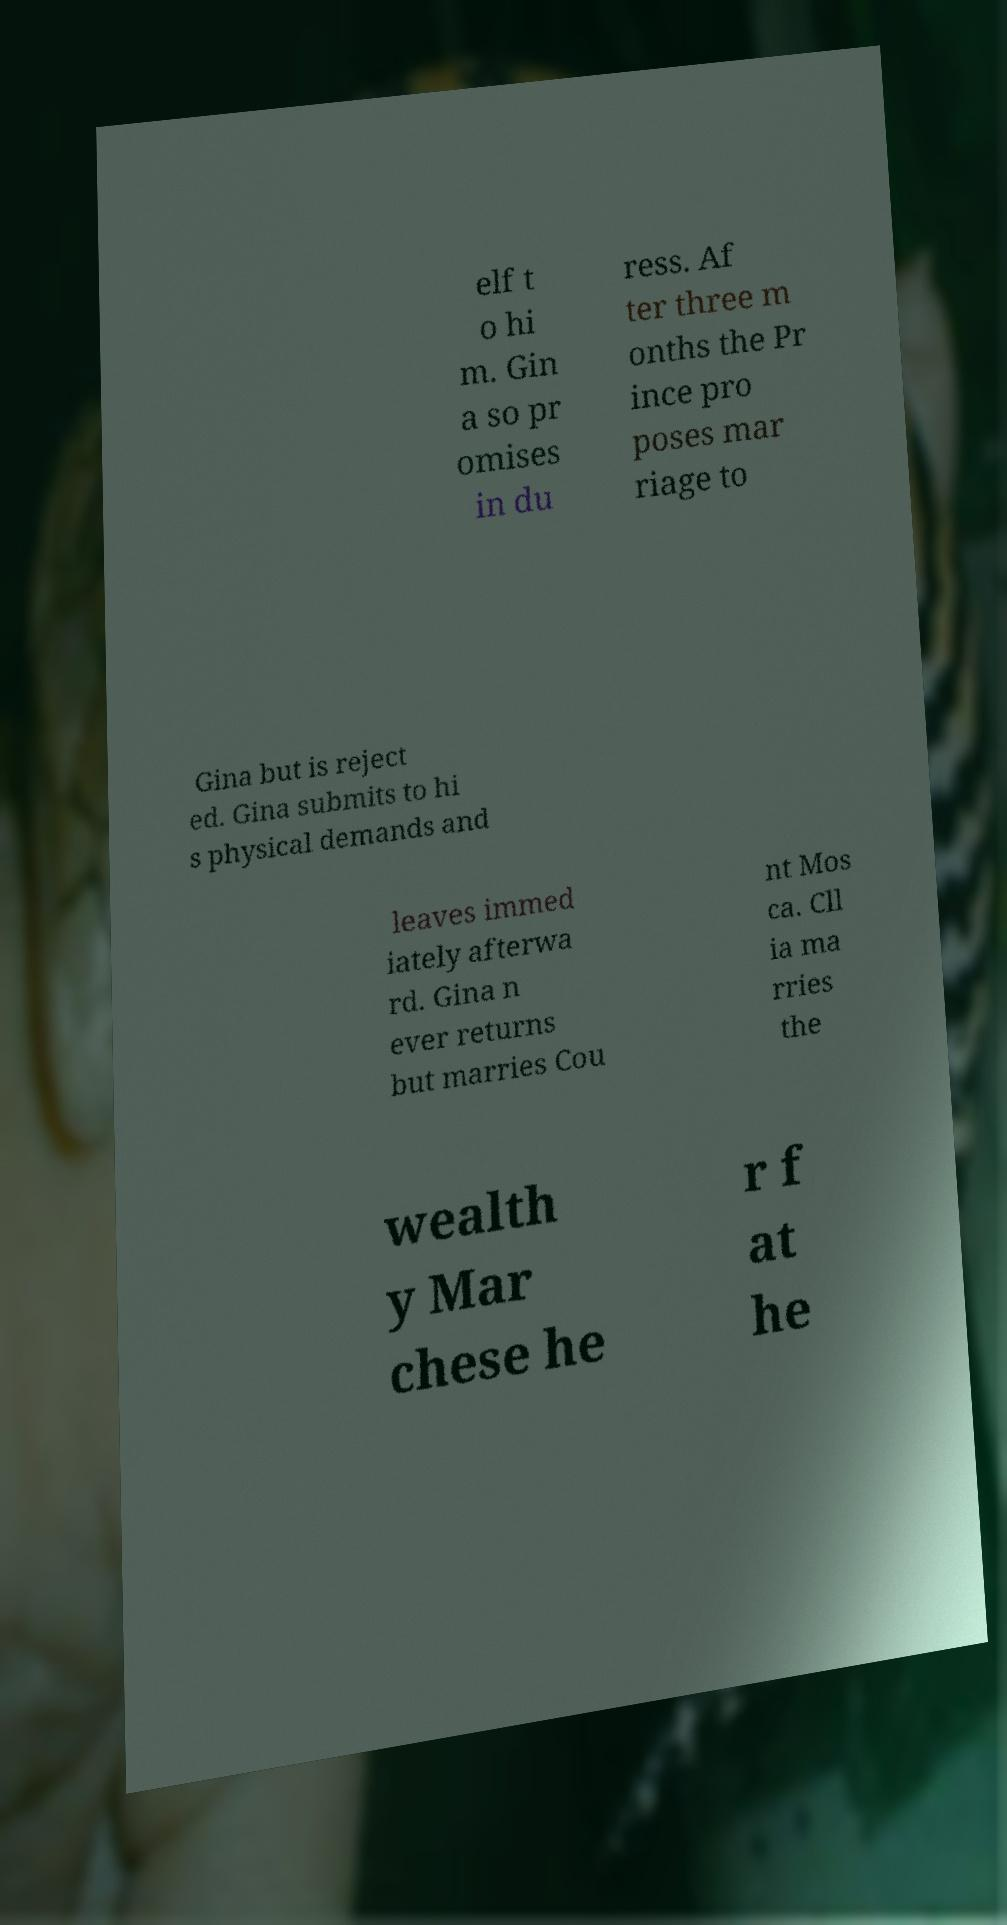Please identify and transcribe the text found in this image. elf t o hi m. Gin a so pr omises in du ress. Af ter three m onths the Pr ince pro poses mar riage to Gina but is reject ed. Gina submits to hi s physical demands and leaves immed iately afterwa rd. Gina n ever returns but marries Cou nt Mos ca. Cll ia ma rries the wealth y Mar chese he r f at he 